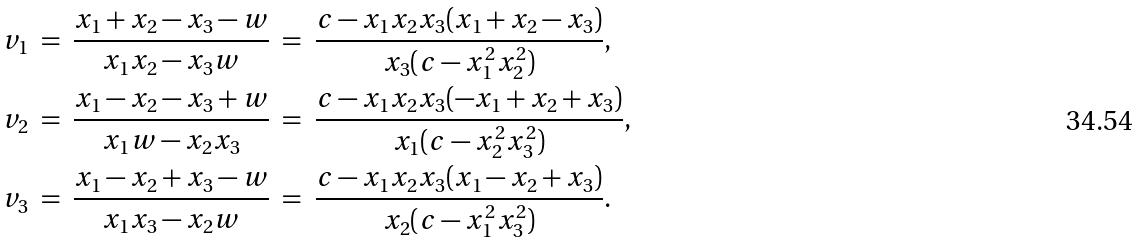<formula> <loc_0><loc_0><loc_500><loc_500>v _ { 1 } \ & = \ \frac { x _ { 1 } + x _ { 2 } - x _ { 3 } - w } { x _ { 1 } x _ { 2 } - x _ { 3 } w } \ = \ \frac { c - x _ { 1 } x _ { 2 } x _ { 3 } ( x _ { 1 } + x _ { 2 } - x _ { 3 } ) } { x _ { 3 } ( c - x _ { 1 } ^ { 2 } x _ { 2 } ^ { 2 } ) } , \\ v _ { 2 } \ & = \ \frac { x _ { 1 } - x _ { 2 } - x _ { 3 } + w } { x _ { 1 } w - x _ { 2 } x _ { 3 } } \ = \ \frac { c - x _ { 1 } x _ { 2 } x _ { 3 } ( - x _ { 1 } + x _ { 2 } + x _ { 3 } ) } { x _ { 1 } ( c - x _ { 2 } ^ { 2 } x _ { 3 } ^ { 2 } ) } , \\ v _ { 3 } \ & = \ \frac { x _ { 1 } - x _ { 2 } + x _ { 3 } - w } { x _ { 1 } x _ { 3 } - x _ { 2 } w } \ = \ \frac { c - x _ { 1 } x _ { 2 } x _ { 3 } ( x _ { 1 } - x _ { 2 } + x _ { 3 } ) } { x _ { 2 } ( c - x _ { 1 } ^ { 2 } x _ { 3 } ^ { 2 } ) } .</formula> 